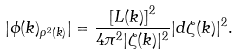<formula> <loc_0><loc_0><loc_500><loc_500>| \phi ( k ) _ { \rho ^ { 2 } ( k ) } | = \frac { \left [ L ( k ) \right ] ^ { 2 } } { 4 \pi ^ { 2 } | \zeta ( k ) | ^ { 2 } } | d \zeta ( k ) | ^ { 2 } .</formula> 